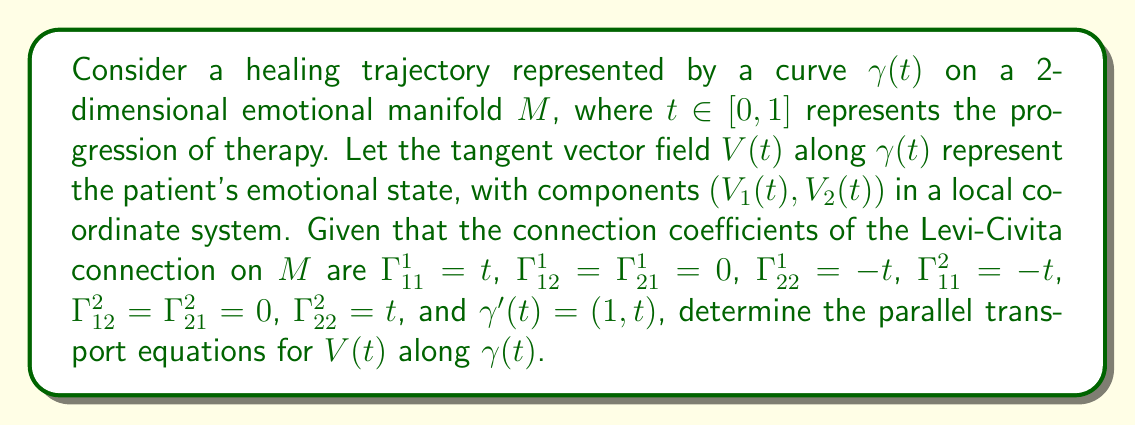Can you solve this math problem? To solve this problem, we'll follow these steps:

1) The parallel transport equation for a vector field $V(t)$ along a curve $\gamma(t)$ is given by:

   $$\frac{DV}{dt} = \nabla_{\gamma'(t)}V = 0$$

2) In component form, this equation becomes:

   $$\frac{dV^i}{dt} + \Gamma_{jk}^i V^j \gamma'^k = 0$$

   for $i = 1, 2$

3) We're given that $\gamma'(t) = (1, t)$, so $\gamma'^1 = 1$ and $\gamma'^2 = t$

4) For $i = 1$:

   $$\frac{dV^1}{dt} + \Gamma_{11}^1 V^1 \gamma'^1 + \Gamma_{12}^1 V^1 \gamma'^2 + \Gamma_{21}^1 V^2 \gamma'^1 + \Gamma_{22}^1 V^2 \gamma'^2 = 0$$

   Substituting the given values:

   $$\frac{dV^1}{dt} + t V^1 \cdot 1 + 0 \cdot V^1 \cdot t + 0 \cdot V^2 \cdot 1 + (-t) \cdot V^2 \cdot t = 0$$

   Simplifying:

   $$\frac{dV^1}{dt} + t V^1 - t^2 V^2 = 0$$

5) For $i = 2$:

   $$\frac{dV^2}{dt} + \Gamma_{11}^2 V^1 \gamma'^1 + \Gamma_{12}^2 V^1 \gamma'^2 + \Gamma_{21}^2 V^2 \gamma'^1 + \Gamma_{22}^2 V^2 \gamma'^2 = 0$$

   Substituting the given values:

   $$\frac{dV^2}{dt} + (-t) \cdot V^1 \cdot 1 + 0 \cdot V^1 \cdot t + 0 \cdot V^2 \cdot 1 + t \cdot V^2 \cdot t = 0$$

   Simplifying:

   $$\frac{dV^2}{dt} - t V^1 + t^2 V^2 = 0$$

6) The parallel transport equations for $V(t)$ along $\gamma(t)$ are therefore:

   $$\frac{dV^1}{dt} + t V^1 - t^2 V^2 = 0$$
   $$\frac{dV^2}{dt} - t V^1 + t^2 V^2 = 0$$
Answer: $$\begin{cases}
\frac{dV^1}{dt} + t V^1 - t^2 V^2 = 0 \\
\frac{dV^2}{dt} - t V^1 + t^2 V^2 = 0
\end{cases}$$ 